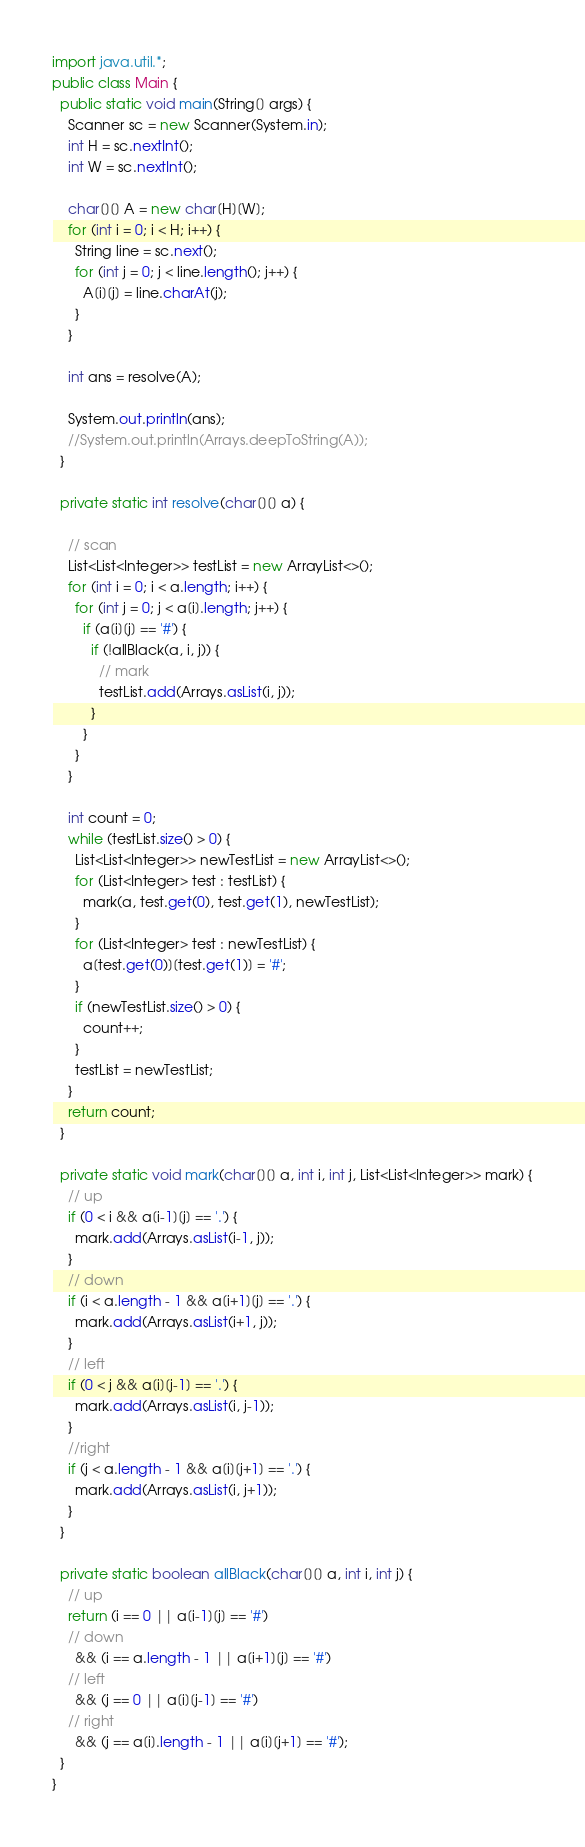Convert code to text. <code><loc_0><loc_0><loc_500><loc_500><_Java_>import java.util.*;
public class Main {
  public static void main(String[] args) {
    Scanner sc = new Scanner(System.in);
    int H = sc.nextInt();
    int W = sc.nextInt();

    char[][] A = new char[H][W];
    for (int i = 0; i < H; i++) {
      String line = sc.next();
      for (int j = 0; j < line.length(); j++) {
        A[i][j] = line.charAt(j);
      }
    }
    
    int ans = resolve(A);
    
    System.out.println(ans);
    //System.out.println(Arrays.deepToString(A));
  }

  private static int resolve(char[][] a) {
    
    // scan
    List<List<Integer>> testList = new ArrayList<>();
    for (int i = 0; i < a.length; i++) {
      for (int j = 0; j < a[i].length; j++) {
        if (a[i][j] == '#') {
          if (!allBlack(a, i, j)) {
            // mark
            testList.add(Arrays.asList(i, j));
          }
        }
      }
    }
    
    int count = 0;
    while (testList.size() > 0) {
      List<List<Integer>> newTestList = new ArrayList<>();
      for (List<Integer> test : testList) {
        mark(a, test.get(0), test.get(1), newTestList);
      }
      for (List<Integer> test : newTestList) {
        a[test.get(0)][test.get(1)] = '#';
      }
      if (newTestList.size() > 0) {
        count++;
      }
      testList = newTestList;
    }
    return count;
  }
  
  private static void mark(char[][] a, int i, int j, List<List<Integer>> mark) {
    // up
    if (0 < i && a[i-1][j] == '.') {
      mark.add(Arrays.asList(i-1, j));
    }
    // down
    if (i < a.length - 1 && a[i+1][j] == '.') {
      mark.add(Arrays.asList(i+1, j));
    }
    // left
    if (0 < j && a[i][j-1] == '.') {
      mark.add(Arrays.asList(i, j-1));
    }
    //right
    if (j < a.length - 1 && a[i][j+1] == '.') {
      mark.add(Arrays.asList(i, j+1));
    }
  }
  
  private static boolean allBlack(char[][] a, int i, int j) {
    // up
    return (i == 0 || a[i-1][j] == '#')
    // down
      && (i == a.length - 1 || a[i+1][j] == '#')
    // left
      && (j == 0 || a[i][j-1] == '#')
    // right
      && (j == a[i].length - 1 || a[i][j+1] == '#');
  } 
}
</code> 